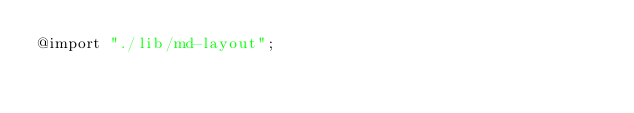Convert code to text. <code><loc_0><loc_0><loc_500><loc_500><_CSS_>@import "./lib/md-layout";
</code> 